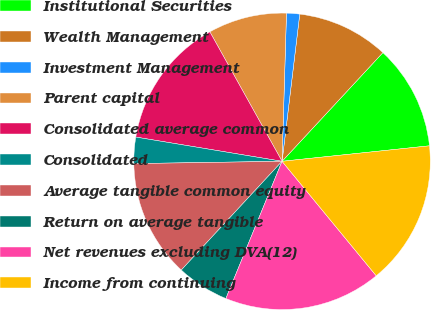Convert chart. <chart><loc_0><loc_0><loc_500><loc_500><pie_chart><fcel>Institutional Securities<fcel>Wealth Management<fcel>Investment Management<fcel>Parent capital<fcel>Consolidated average common<fcel>Consolidated<fcel>Average tangible common equity<fcel>Return on average tangible<fcel>Net revenues excluding DVA(12)<fcel>Income from continuing<nl><fcel>11.43%<fcel>10.0%<fcel>1.43%<fcel>8.57%<fcel>14.29%<fcel>2.86%<fcel>12.86%<fcel>5.71%<fcel>17.14%<fcel>15.71%<nl></chart> 